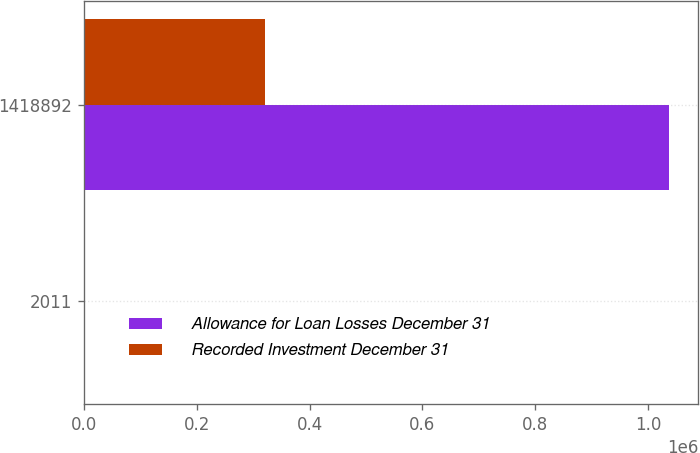Convert chart. <chart><loc_0><loc_0><loc_500><loc_500><stacked_bar_chart><ecel><fcel>2011<fcel>1418892<nl><fcel>Allowance for Loan Losses December 31<fcel>2010<fcel>1.03687e+06<nl><fcel>Recorded Investment December 31<fcel>2011<fcel>320143<nl></chart> 